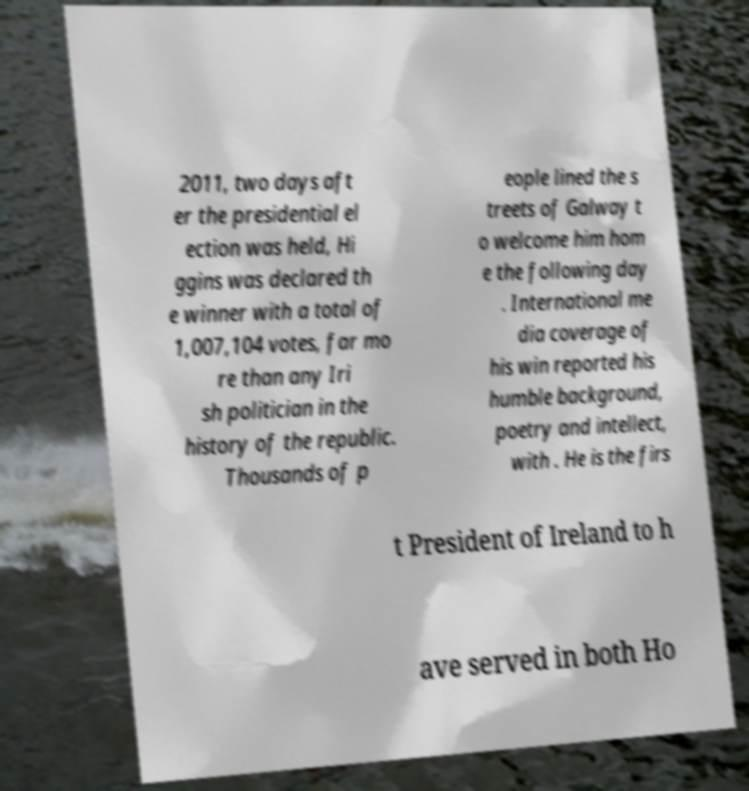Could you extract and type out the text from this image? 2011, two days aft er the presidential el ection was held, Hi ggins was declared th e winner with a total of 1,007,104 votes, far mo re than any Iri sh politician in the history of the republic. Thousands of p eople lined the s treets of Galway t o welcome him hom e the following day . International me dia coverage of his win reported his humble background, poetry and intellect, with . He is the firs t President of Ireland to h ave served in both Ho 